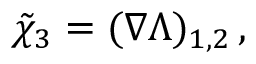Convert formula to latex. <formula><loc_0><loc_0><loc_500><loc_500>\tilde { \chi } _ { 3 } = ( \nabla \Lambda ) _ { 1 , 2 } \, ,</formula> 